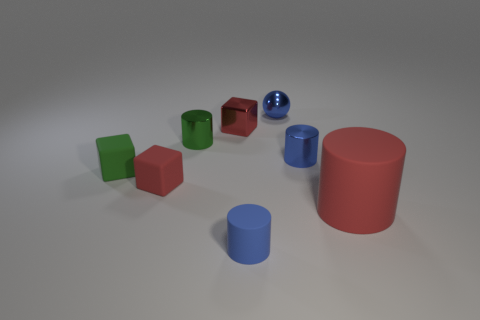What shape is the metallic object that is the same color as the small ball?
Provide a succinct answer. Cylinder. The metal object that is the same color as the big cylinder is what size?
Provide a succinct answer. Small. Does the large matte object have the same color as the tiny block behind the blue metal cylinder?
Keep it short and to the point. Yes. What shape is the shiny thing behind the small red thing that is behind the red cube to the left of the green cylinder?
Provide a succinct answer. Sphere. Is the size of the blue matte cylinder the same as the red matte thing that is to the left of the small red shiny object?
Make the answer very short. Yes. What is the color of the object that is both in front of the small green rubber cube and to the right of the sphere?
Offer a terse response. Red. What number of other things are the same shape as the small green rubber thing?
Make the answer very short. 2. Does the rubber cylinder to the right of the small blue rubber object have the same color as the block to the right of the red matte block?
Offer a very short reply. Yes. Does the blue metallic thing that is behind the shiny block have the same size as the matte thing that is on the right side of the small blue ball?
Provide a short and direct response. No. What material is the red object that is behind the metal cylinder that is left of the small shiny cylinder that is on the right side of the shiny block?
Ensure brevity in your answer.  Metal. 